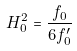Convert formula to latex. <formula><loc_0><loc_0><loc_500><loc_500>H _ { 0 } ^ { 2 } = \frac { f _ { 0 } } { 6 f _ { 0 } ^ { \prime } }</formula> 